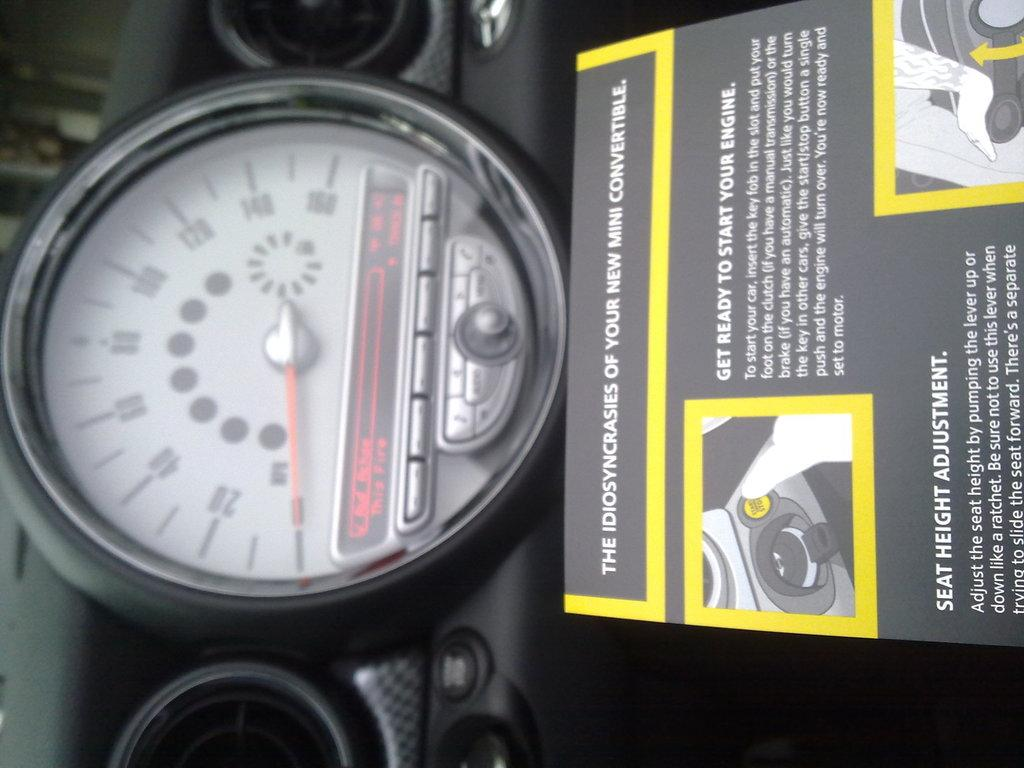What type of vehicle is shown in the image? The image shows an inside view of a car. What instrument is visible in the car? There is a speedometer visible in the car. What else can be seen in the image besides the speedometer? There is a poster with text in the image. What type of circle can be seen in the image? There is no circle present in the image. How does the lift function in the car? There is no lift present in the car; it is an enclosed vehicle without any lifting mechanisms. 